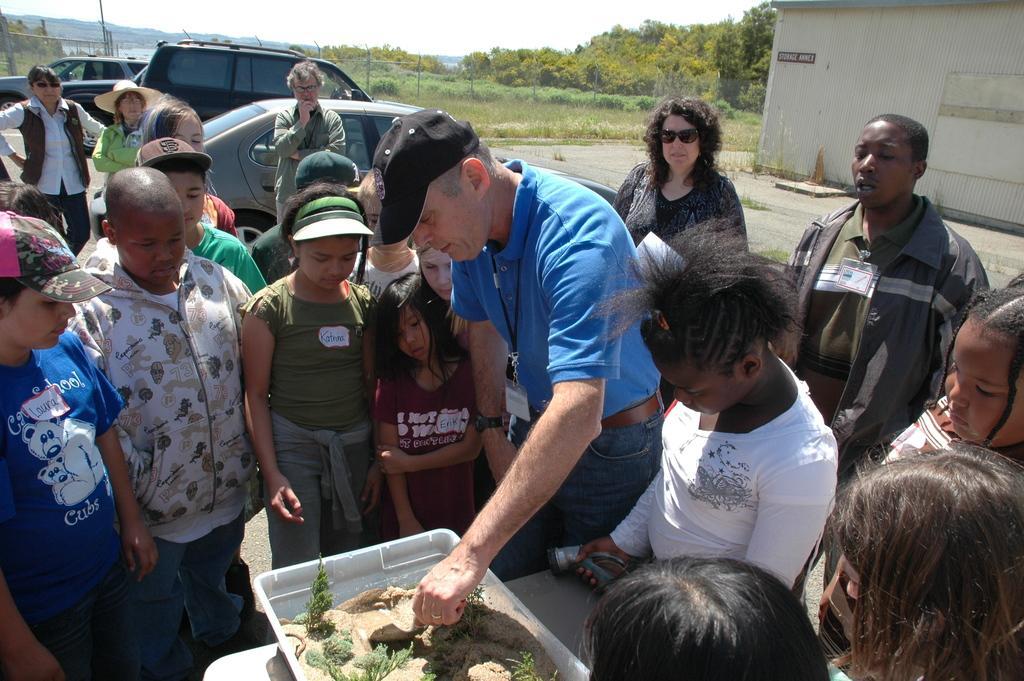In one or two sentences, can you explain what this image depicts? In this picture, we see many people are standing on the road. At the bottom of the picture, we see a table on which a tube containing herbs and soil is placed. The man in blue T-shirt who is wearing a black cap is holding something in his hand. Behind them, we see cars parked on the road. On the right side, we see a building in white color. There are trees, poles and hills in the background. At the top of the picture, we see the sky. 